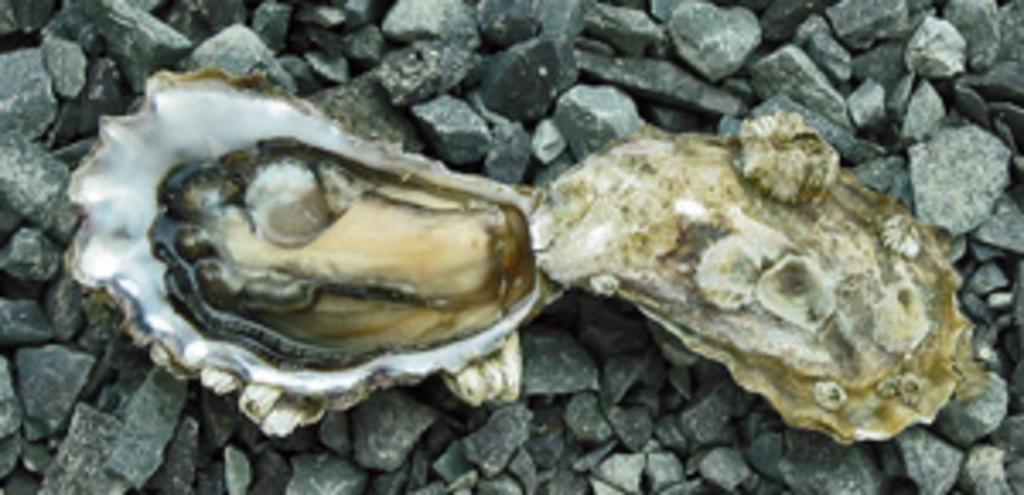How would you summarize this image in a sentence or two? In this image I can see the shell. In the background, I can see the stones. 